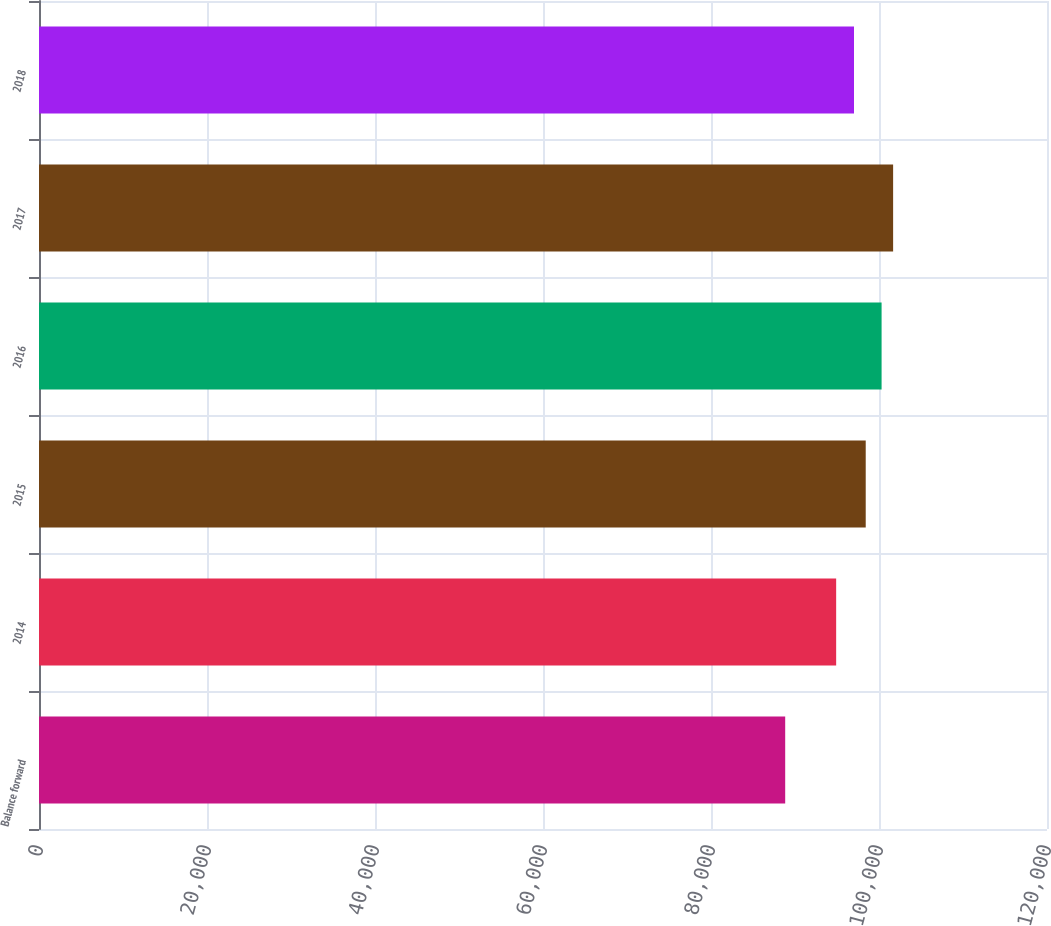Convert chart. <chart><loc_0><loc_0><loc_500><loc_500><bar_chart><fcel>Balance forward<fcel>2014<fcel>2015<fcel>2016<fcel>2017<fcel>2018<nl><fcel>88833<fcel>94900<fcel>98419<fcel>100308<fcel>101681<fcel>97024<nl></chart> 